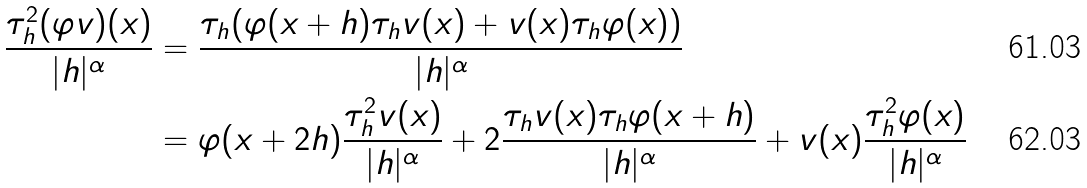<formula> <loc_0><loc_0><loc_500><loc_500>\frac { \tau ^ { 2 } _ { h } ( \varphi v ) ( x ) } { | h | ^ { \alpha } } & = \frac { \tau _ { h } ( \varphi ( x + h ) \tau _ { h } v ( x ) + v ( x ) \tau _ { h } \varphi ( x ) ) } { | h | ^ { \alpha } } \\ & = \varphi ( x + 2 h ) \frac { \tau ^ { 2 } _ { h } v ( x ) } { | h | ^ { \alpha } } + 2 \frac { \tau _ { h } v ( x ) \tau _ { h } \varphi ( x + h ) } { | h | ^ { \alpha } } + v ( x ) \frac { \tau ^ { 2 } _ { h } \varphi ( x ) } { | h | ^ { \alpha } }</formula> 